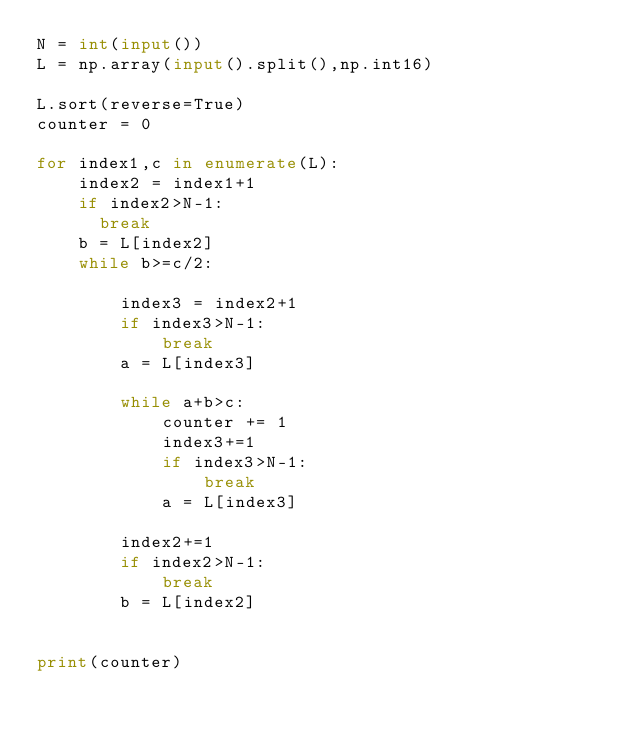Convert code to text. <code><loc_0><loc_0><loc_500><loc_500><_Python_>N = int(input())
L = np.array(input().split(),np.int16)

L.sort(reverse=True)
counter = 0

for index1,c in enumerate(L):
    index2 = index1+1
    if index2>N-1:
      break
    b = L[index2]
    while b>=c/2:
        
        index3 = index2+1
        if index3>N-1:
            break
        a = L[index3]
        
        while a+b>c:
            counter += 1
            index3+=1
            if index3>N-1:
                break
            a = L[index3]

        index2+=1
        if index2>N-1:
            break
        b = L[index2]


print(counter)</code> 